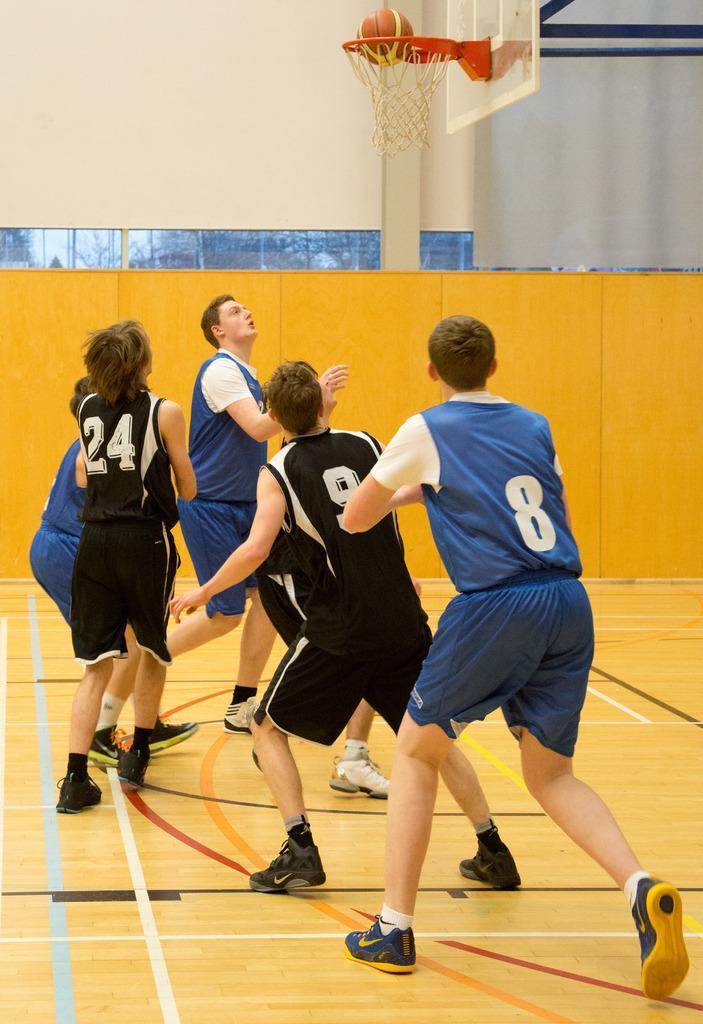Can you describe this image briefly? In this image we can see a group of people on the ground. We can also see a goal post, ball, a banner and a wall. 